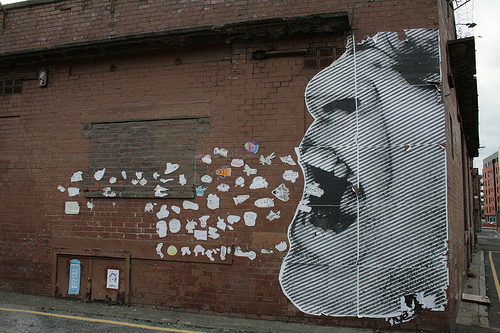<image>
Is there a decals next to the person? Yes. The decals is positioned adjacent to the person, located nearby in the same general area. 